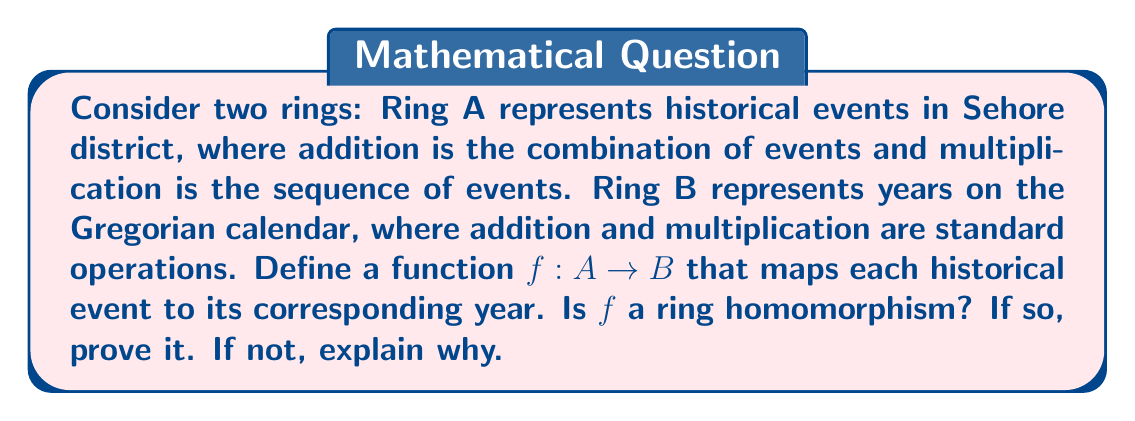What is the answer to this math problem? To determine if $f$ is a ring homomorphism, we need to check if it satisfies the two conditions for ring homomorphisms:

1. $f(a + b) = f(a) + f(b)$ for all $a, b \in A$
2. $f(a \cdot b) = f(a) \cdot f(b)$ for all $a, b \in A$

Let's examine each condition:

1. Addition:
For historical events $a$ and $b$ in Ring A, $f(a + b)$ represents the year of the combined events. This is not necessarily equal to $f(a) + f(b)$, which would be the sum of the individual years. For example, if $a$ is the founding of a school in 1950 and $b$ is the construction of a monument in 1980:

   $f(a + b) = 1980$ (year of the latest event)
   $f(a) + f(b) = 1950 + 1980 = 3930$

Clearly, $f(a + b) \neq f(a) + f(b)$

2. Multiplication:
For historical events $a$ and $b$ in Ring A, $f(a \cdot b)$ represents the year of the sequence of events, which would be the year of the later event. This is not equal to $f(a) \cdot f(b)$, which would be the product of the years. Using the same example:

   $f(a \cdot b) = 1980$ (year of the later event)
   $f(a) \cdot f(b) = 1950 \cdot 1980 = 3,861,000$

Again, $f(a \cdot b) \neq f(a) \cdot f(b)$

Since $f$ does not satisfy either condition for a ring homomorphism, we conclude that $f$ is not a ring homomorphism.
Answer: $f$ is not a ring homomorphism because it does not preserve the ring operations of addition and multiplication when mapping from Ring A to Ring B. 